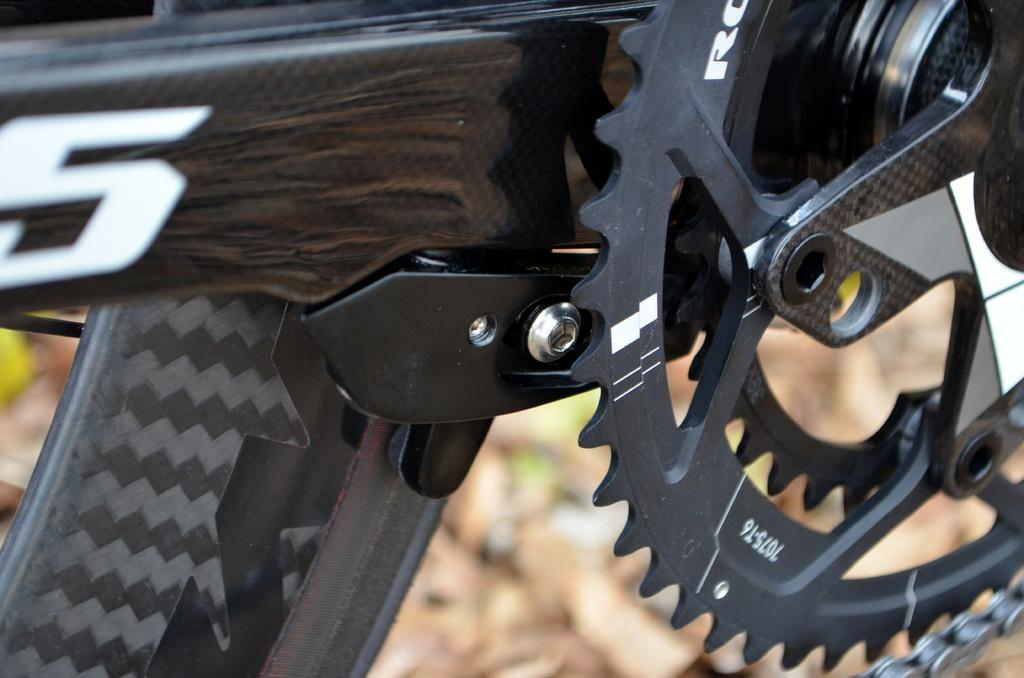What is the main object in the image? There is a bicycle in the image. What material is the wheel of the bicycle made of? The wheel of the bicycle is made of metal. What is attached to the wheel of the bicycle? The wheel has a chain. What type of environment is visible in the background of the image? The background of the image includes land. What type of music can be heard playing in the background of the image? There is no music present in the image, as it is a still photograph of a bicycle. What type of authority figure is visible in the image? There is no authority figure present in the image; it features a bicycle with a metal wheel and a chain. 